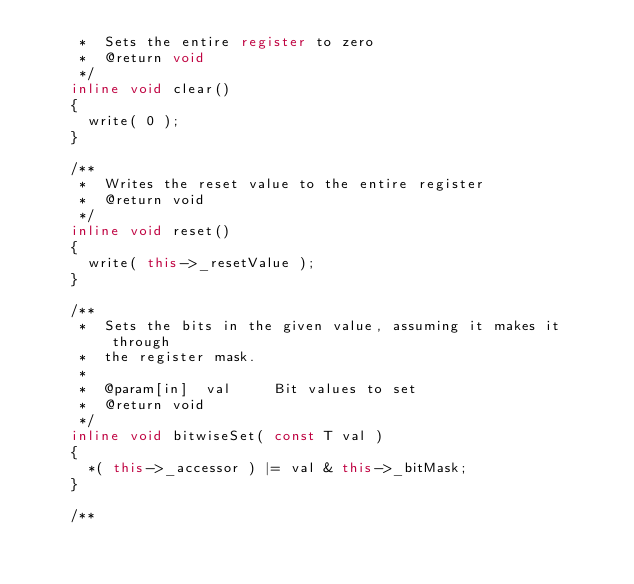<code> <loc_0><loc_0><loc_500><loc_500><_C++_>     *  Sets the entire register to zero
     *  @return void
     */
    inline void clear()
    {
      write( 0 );
    }

    /**
     *  Writes the reset value to the entire register
     *  @return void
     */
    inline void reset()
    {
      write( this->_resetValue );
    }

    /**
     *  Sets the bits in the given value, assuming it makes it through
     *  the register mask.
     *
     *  @param[in]  val     Bit values to set
     *  @return void
     */
    inline void bitwiseSet( const T val )
    {
      *( this->_accessor ) |= val & this->_bitMask;
    }

    /**</code> 